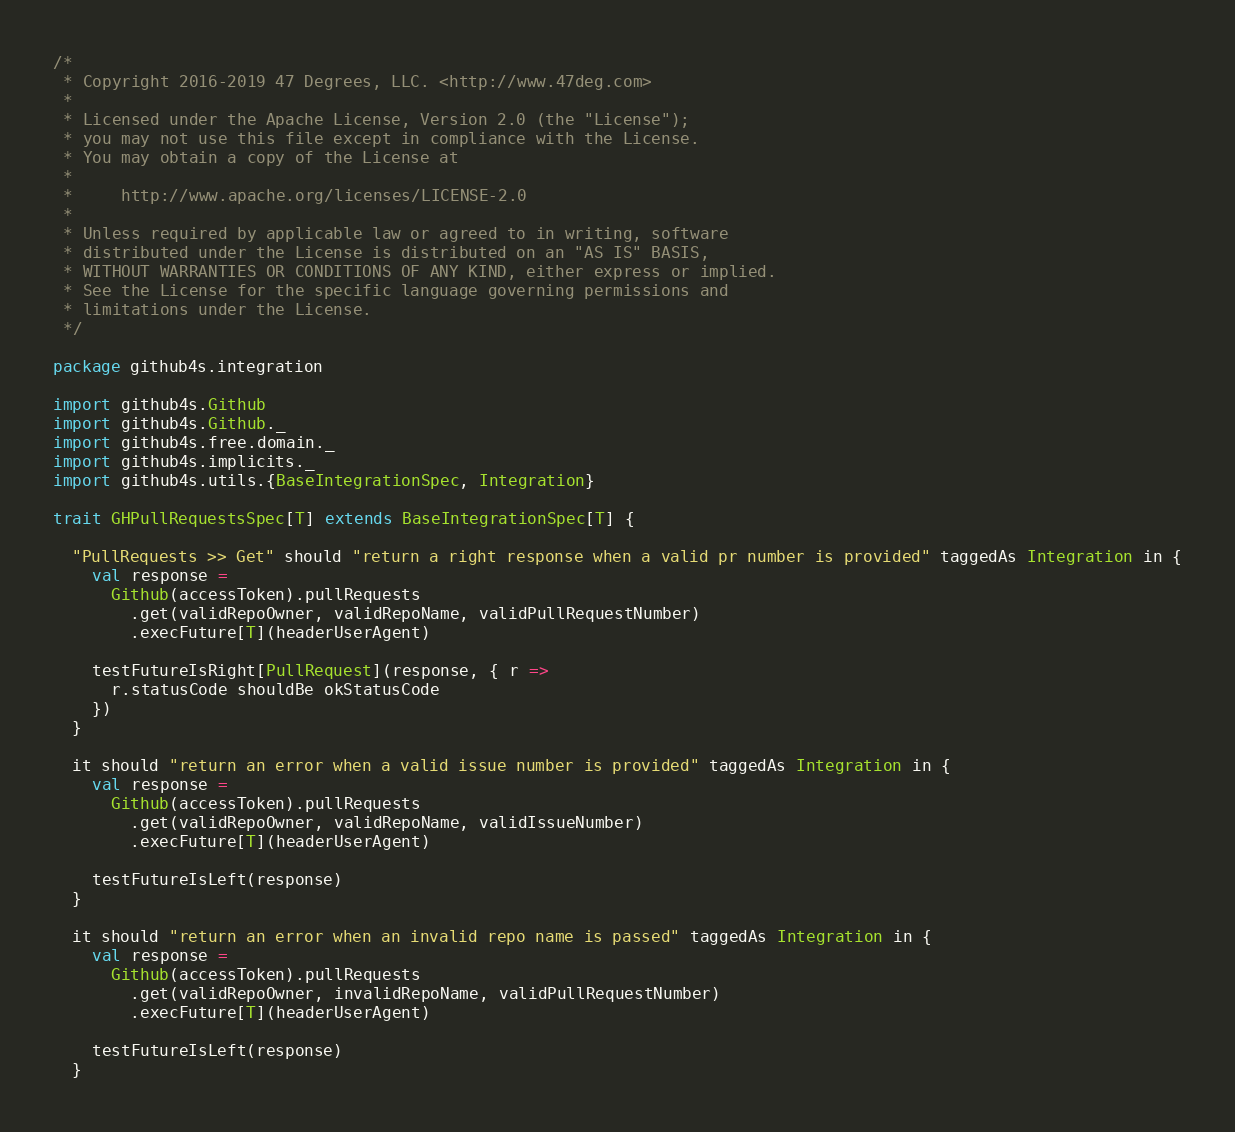Convert code to text. <code><loc_0><loc_0><loc_500><loc_500><_Scala_>/*
 * Copyright 2016-2019 47 Degrees, LLC. <http://www.47deg.com>
 *
 * Licensed under the Apache License, Version 2.0 (the "License");
 * you may not use this file except in compliance with the License.
 * You may obtain a copy of the License at
 *
 *     http://www.apache.org/licenses/LICENSE-2.0
 *
 * Unless required by applicable law or agreed to in writing, software
 * distributed under the License is distributed on an "AS IS" BASIS,
 * WITHOUT WARRANTIES OR CONDITIONS OF ANY KIND, either express or implied.
 * See the License for the specific language governing permissions and
 * limitations under the License.
 */

package github4s.integration

import github4s.Github
import github4s.Github._
import github4s.free.domain._
import github4s.implicits._
import github4s.utils.{BaseIntegrationSpec, Integration}

trait GHPullRequestsSpec[T] extends BaseIntegrationSpec[T] {

  "PullRequests >> Get" should "return a right response when a valid pr number is provided" taggedAs Integration in {
    val response =
      Github(accessToken).pullRequests
        .get(validRepoOwner, validRepoName, validPullRequestNumber)
        .execFuture[T](headerUserAgent)

    testFutureIsRight[PullRequest](response, { r =>
      r.statusCode shouldBe okStatusCode
    })
  }

  it should "return an error when a valid issue number is provided" taggedAs Integration in {
    val response =
      Github(accessToken).pullRequests
        .get(validRepoOwner, validRepoName, validIssueNumber)
        .execFuture[T](headerUserAgent)

    testFutureIsLeft(response)
  }

  it should "return an error when an invalid repo name is passed" taggedAs Integration in {
    val response =
      Github(accessToken).pullRequests
        .get(validRepoOwner, invalidRepoName, validPullRequestNumber)
        .execFuture[T](headerUserAgent)

    testFutureIsLeft(response)
  }
</code> 